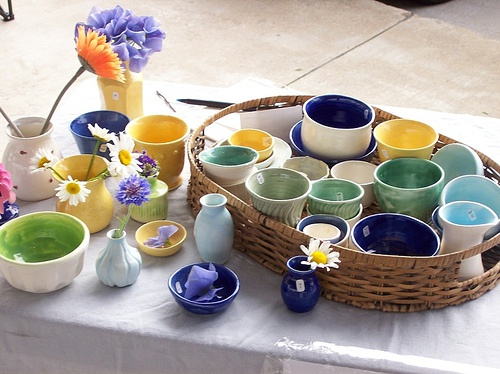Describe the objects in this image and their specific colors. I can see bowl in ivory, darkgray, darkgreen, green, and olive tones, vase in ivory, darkgray, darkgreen, green, and olive tones, potted plant in ivory, violet, lightgray, tan, and blue tones, cup in ivory, navy, and tan tones, and bowl in ivory, navy, and tan tones in this image. 